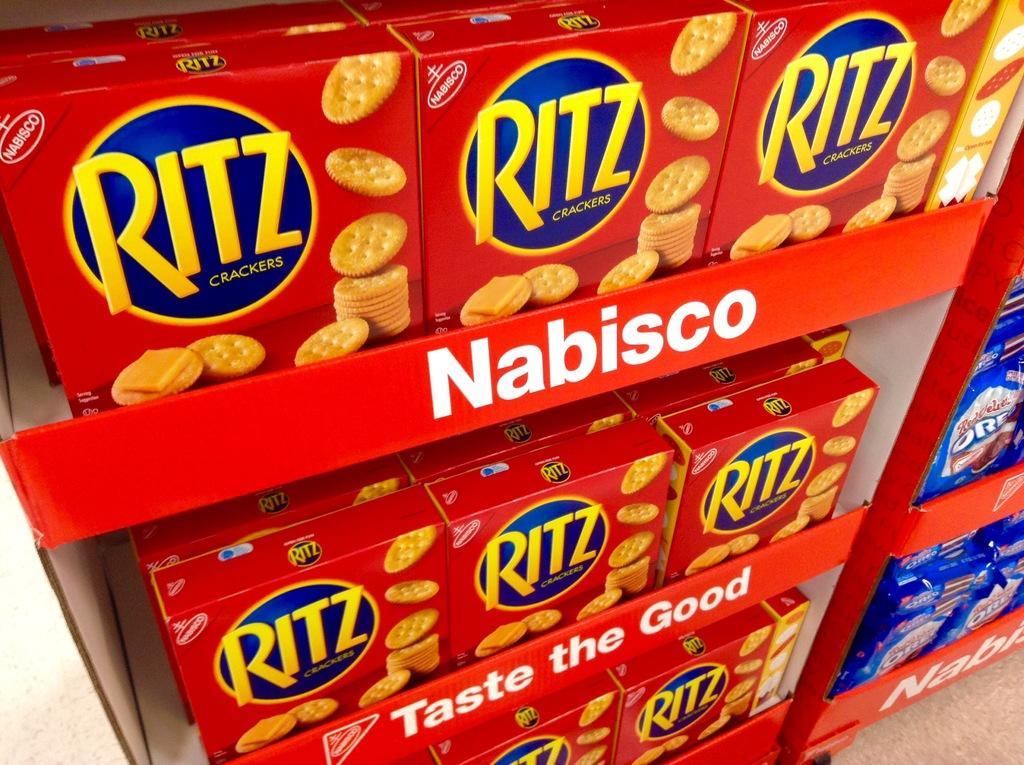Could you give a brief overview of what you see in this image? In this image we can see many food products placed on the racks. There is some text in the image. 